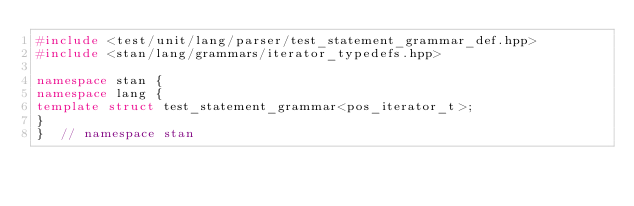<code> <loc_0><loc_0><loc_500><loc_500><_C++_>#include <test/unit/lang/parser/test_statement_grammar_def.hpp>
#include <stan/lang/grammars/iterator_typedefs.hpp>

namespace stan {
namespace lang {
template struct test_statement_grammar<pos_iterator_t>;
}
}  // namespace stan
</code> 